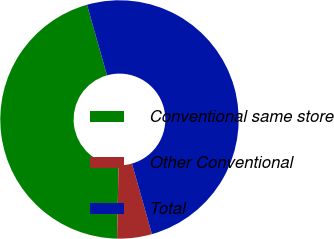<chart> <loc_0><loc_0><loc_500><loc_500><pie_chart><fcel>Conventional same store<fcel>Other Conventional<fcel>Total<nl><fcel>45.29%<fcel>4.71%<fcel>50.0%<nl></chart> 